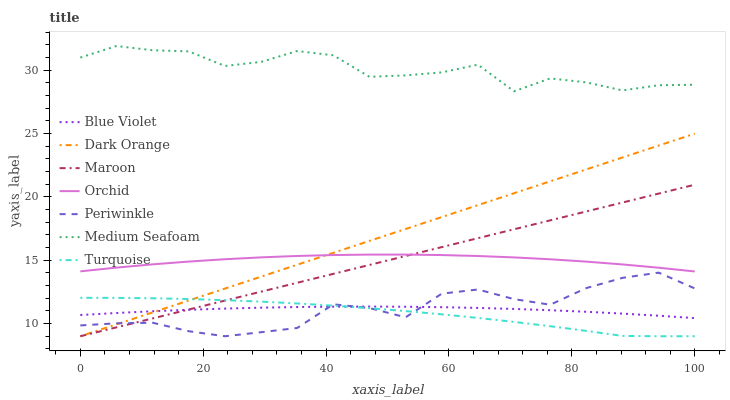Does Turquoise have the minimum area under the curve?
Answer yes or no. Yes. Does Medium Seafoam have the maximum area under the curve?
Answer yes or no. Yes. Does Maroon have the minimum area under the curve?
Answer yes or no. No. Does Maroon have the maximum area under the curve?
Answer yes or no. No. Is Maroon the smoothest?
Answer yes or no. Yes. Is Medium Seafoam the roughest?
Answer yes or no. Yes. Is Turquoise the smoothest?
Answer yes or no. No. Is Turquoise the roughest?
Answer yes or no. No. Does Dark Orange have the lowest value?
Answer yes or no. Yes. Does Medium Seafoam have the lowest value?
Answer yes or no. No. Does Medium Seafoam have the highest value?
Answer yes or no. Yes. Does Turquoise have the highest value?
Answer yes or no. No. Is Turquoise less than Orchid?
Answer yes or no. Yes. Is Orchid greater than Turquoise?
Answer yes or no. Yes. Does Periwinkle intersect Turquoise?
Answer yes or no. Yes. Is Periwinkle less than Turquoise?
Answer yes or no. No. Is Periwinkle greater than Turquoise?
Answer yes or no. No. Does Turquoise intersect Orchid?
Answer yes or no. No. 